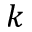Convert formula to latex. <formula><loc_0><loc_0><loc_500><loc_500>k</formula> 